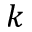Convert formula to latex. <formula><loc_0><loc_0><loc_500><loc_500>k</formula> 